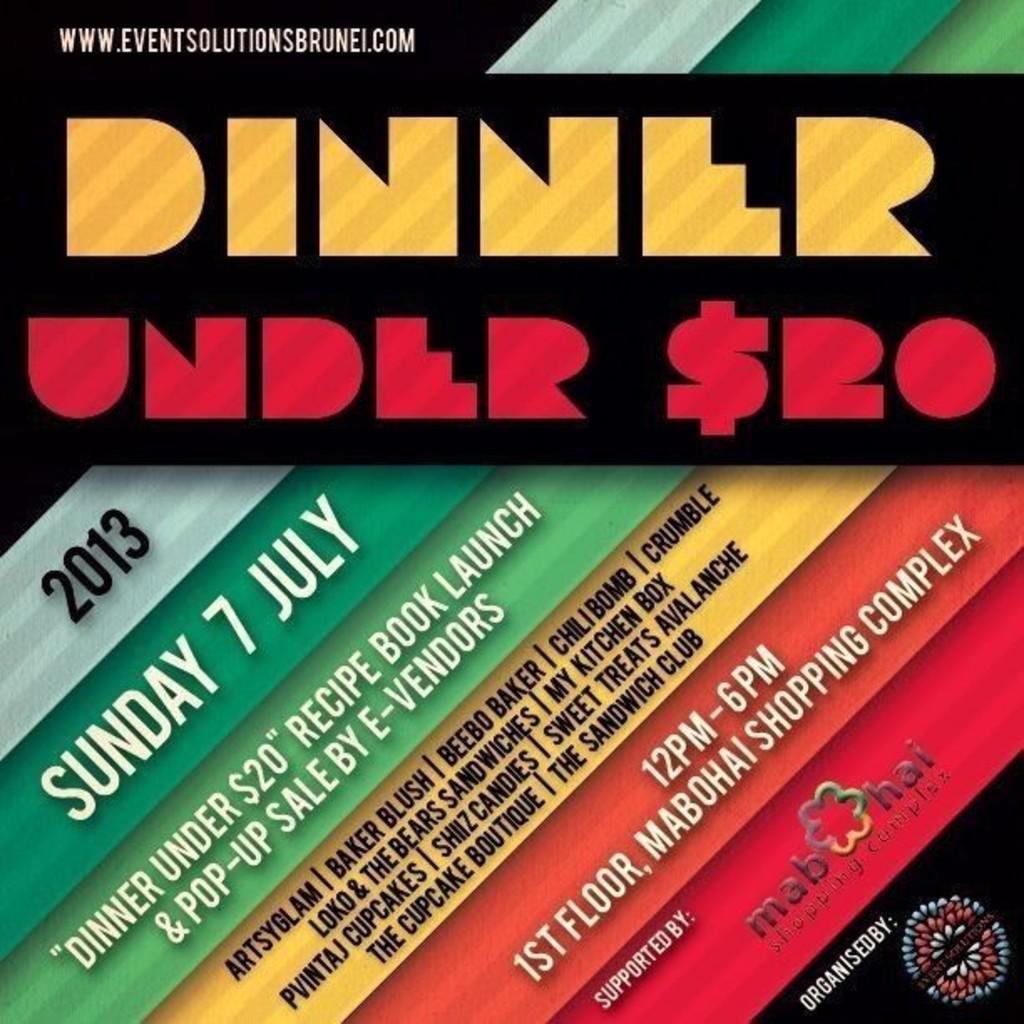What is the price for dinner ?
Give a very brief answer. Under $20. What is the date of the dinner?
Provide a short and direct response. 7 july. 